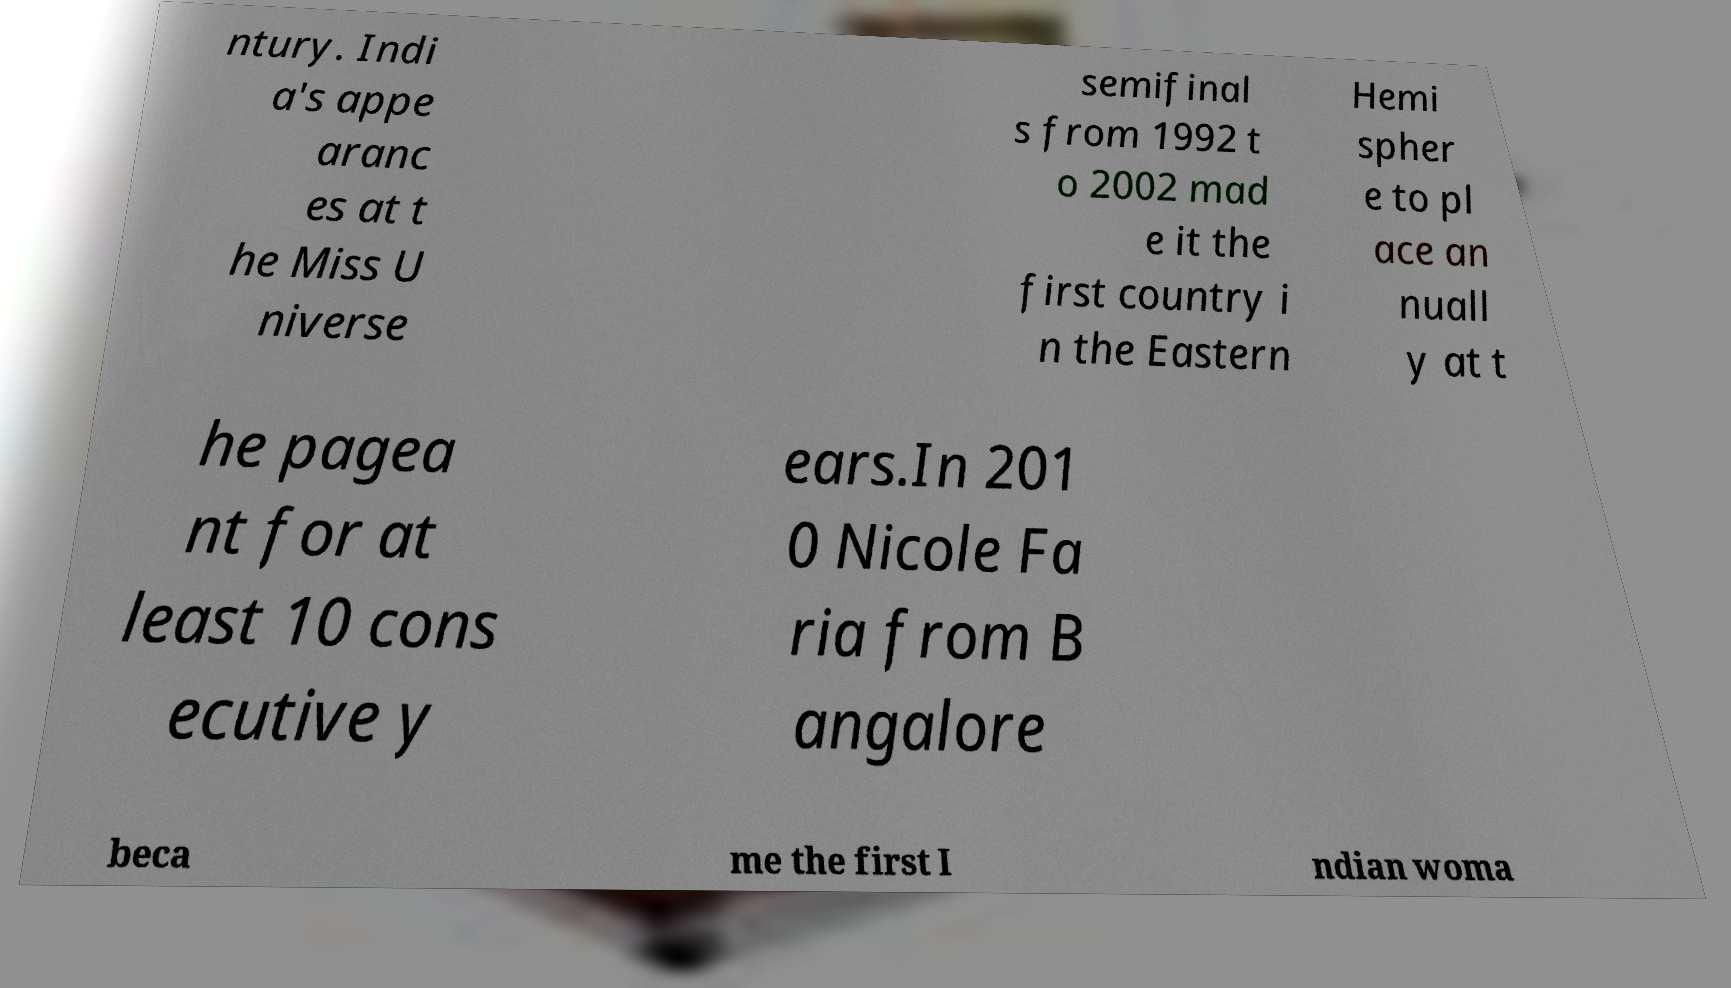What messages or text are displayed in this image? I need them in a readable, typed format. ntury. Indi a's appe aranc es at t he Miss U niverse semifinal s from 1992 t o 2002 mad e it the first country i n the Eastern Hemi spher e to pl ace an nuall y at t he pagea nt for at least 10 cons ecutive y ears.In 201 0 Nicole Fa ria from B angalore beca me the first I ndian woma 